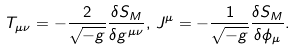<formula> <loc_0><loc_0><loc_500><loc_500>T _ { \mu \nu } = - \frac { 2 } { \sqrt { - g } } \frac { \delta S _ { M } } { \delta g ^ { \mu \nu } } , \, J ^ { \mu } = - \frac { 1 } { \sqrt { - g } } \frac { \delta S _ { M } } { \delta \phi _ { \mu } } .</formula> 